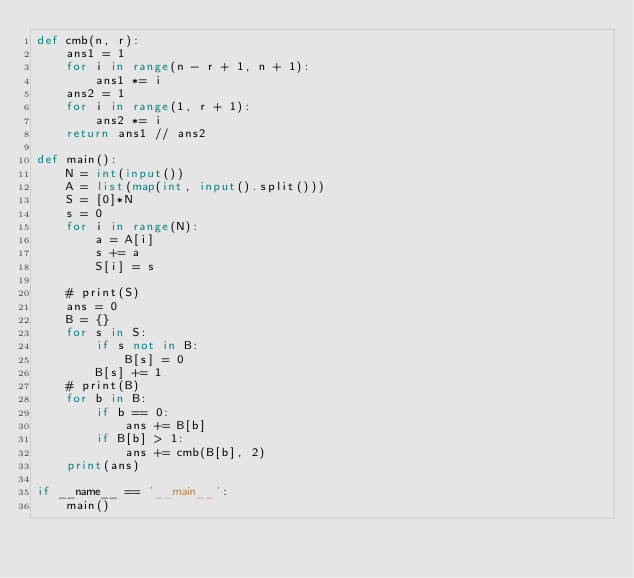<code> <loc_0><loc_0><loc_500><loc_500><_Python_>def cmb(n, r):
    ans1 = 1
    for i in range(n - r + 1, n + 1):
        ans1 *= i
    ans2 = 1
    for i in range(1, r + 1):
        ans2 *= i
    return ans1 // ans2

def main():
    N = int(input())
    A = list(map(int, input().split()))
    S = [0]*N
    s = 0
    for i in range(N):
        a = A[i]
        s += a
        S[i] = s

    # print(S)
    ans = 0
    B = {}
    for s in S:
        if s not in B:
            B[s] = 0
        B[s] += 1
    # print(B)
    for b in B:
        if b == 0:
            ans += B[b]
        if B[b] > 1:
            ans += cmb(B[b], 2)
    print(ans)

if __name__ == '__main__':
    main()
</code> 